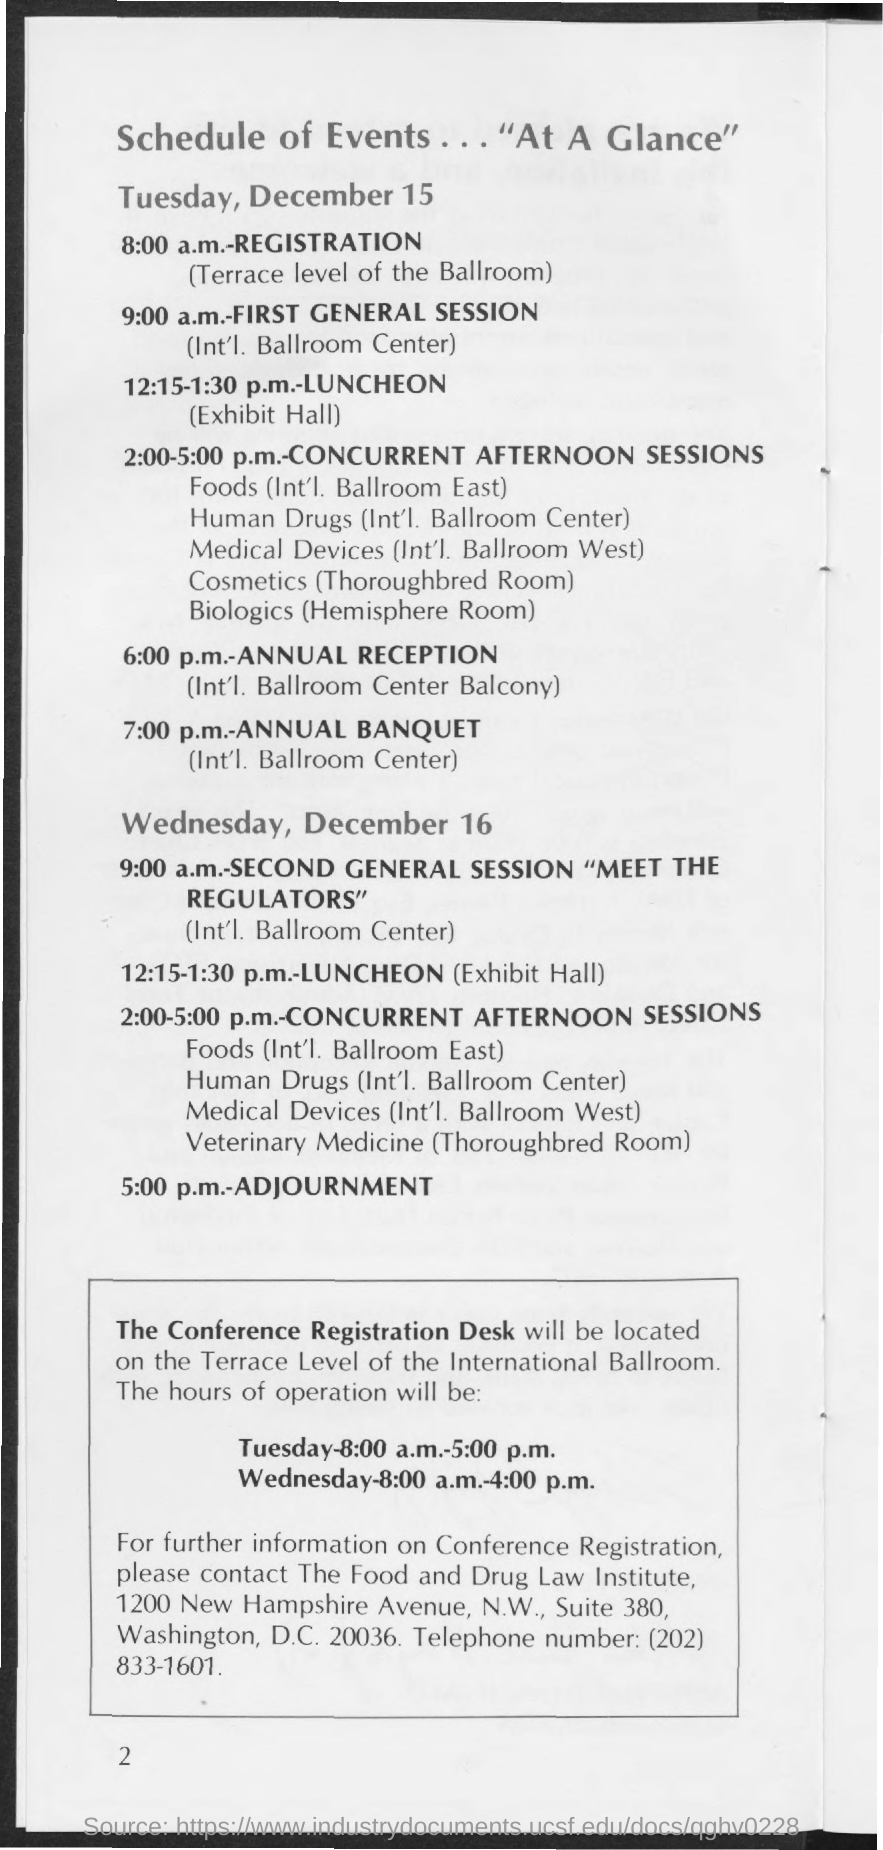Identify some key points in this picture. The First General Session on Tuesday, December 15, is scheduled for 9:00 a.m. On December 15th, the venue for registration is the terrace level of the Ballroom. The time scheduled for registration on Tuesday, December 15 is 8:00 a.m. The Food and Drug Law Institute is located at 1200 New Hampshire Avenue, N.W., Suite 380, in Washington, D.C. The postal address of The Food and Drug Law Institute is 1200 New Hampshire Avenue, N.W., Suite 380, Washington, D.C. 20036. The first general session of December 15 will take place in the International Ballroom Center. 